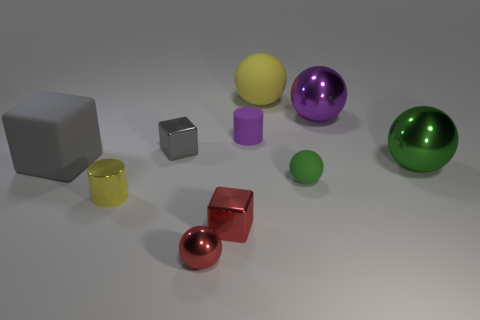There is a large metal thing behind the metal block that is behind the large green thing; what is its shape?
Provide a short and direct response. Sphere. Is the number of matte cubes in front of the large green shiny ball less than the number of rubber objects that are left of the tiny purple object?
Your answer should be compact. Yes. The big matte object that is the same shape as the large purple metal thing is what color?
Your answer should be very brief. Yellow. What number of metallic things are left of the yellow sphere and behind the red block?
Keep it short and to the point. 2. Are there more things that are to the right of the tiny red metal block than gray things in front of the yellow cylinder?
Give a very brief answer. Yes. What is the size of the green matte object?
Ensure brevity in your answer.  Small. Is there a tiny gray metal thing of the same shape as the big gray thing?
Your response must be concise. Yes. Do the green shiny thing and the small object that is in front of the red shiny block have the same shape?
Ensure brevity in your answer.  Yes. There is a metal thing that is left of the large purple thing and behind the small green ball; what is its size?
Make the answer very short. Small. What number of purple shiny things are there?
Provide a short and direct response. 1. 